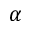Convert formula to latex. <formula><loc_0><loc_0><loc_500><loc_500>\alpha</formula> 